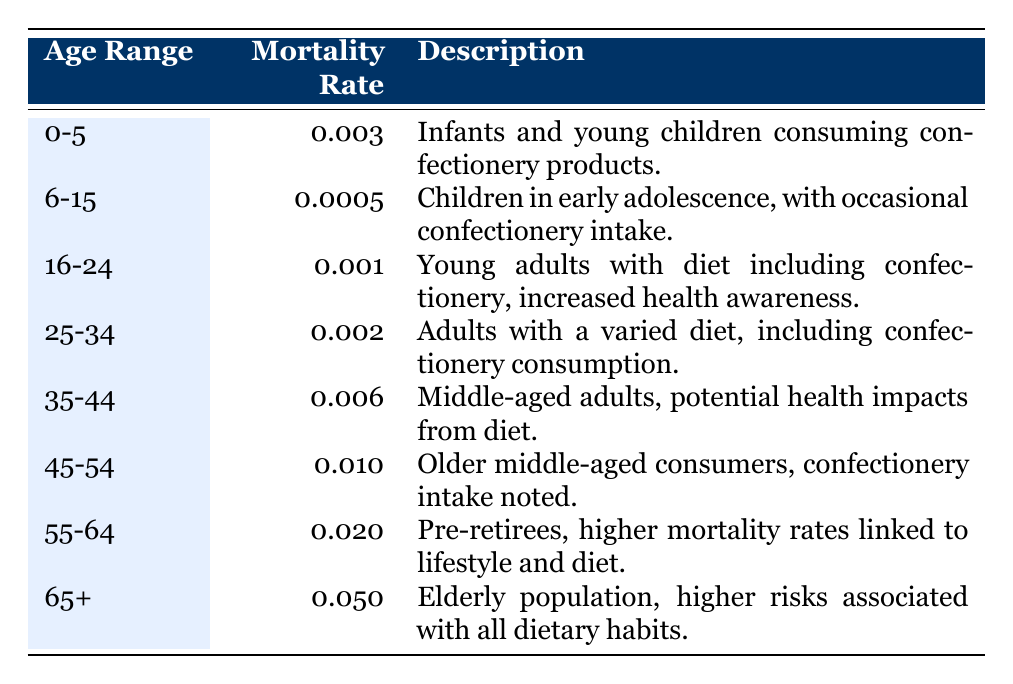What is the mortality rate for the age group 45-54? The table shows that the mortality rate for the age group 45-54 is listed as 0.010.
Answer: 0.010 Which age range has the highest mortality rate? By reviewing the mortality rates listed, the age range 65+ has the highest rate at 0.050.
Answer: 65+ Is the mortality rate for the age range 6-15 higher than that for the age range 0-5? The mortality rate for age range 6-15 is 0.0005, while for age range 0-5 it is 0.003. Since 0.0005 is less than 0.003, the statement is false.
Answer: No What is the average mortality rate for consumers aged 35 and older? The age groups aged 35 and older and their mortality rates are: 35-44 (0.006), 45-54 (0.010), 55-64 (0.020), and 65+ (0.050). The average is calculated by summing these rates: 0.006 + 0.010 + 0.020 + 0.050 = 0.086, and then dividing by 4 (the number of groups), which gives 0.086 / 4 = 0.0215.
Answer: 0.0215 Do children aged 6-15 have a higher mortality rate than young adults aged 16-24? The mortality rate for children aged 6-15 is 0.0005, and for young adults aged 16-24 it is 0.001. Since 0.0005 is less than 0.001, the statement is false.
Answer: No What is the difference in mortality rates between the age groups 25-34 and 55-64? The mortality rates for these age groups are 0.002 (25-34) and 0.020 (55-64). The difference is calculated by subtracting these two rates: 0.020 - 0.002 = 0.018.
Answer: 0.018 Is it true that the mortality rate increases with age among the groups shown? By examining the table, mortality rates do increase with age from 0.003 (0-5) to 0.050 (65+), supporting the statement.
Answer: Yes What is the sum of the mortality rates for the age groups 0-5, 45-54, and 65+? The mortality rates to be summed are: 0.003 (0-5), 0.010 (45-54), and 0.050 (65+). Adding these together, we get: 0.003 + 0.010 + 0.050 = 0.063.
Answer: 0.063 